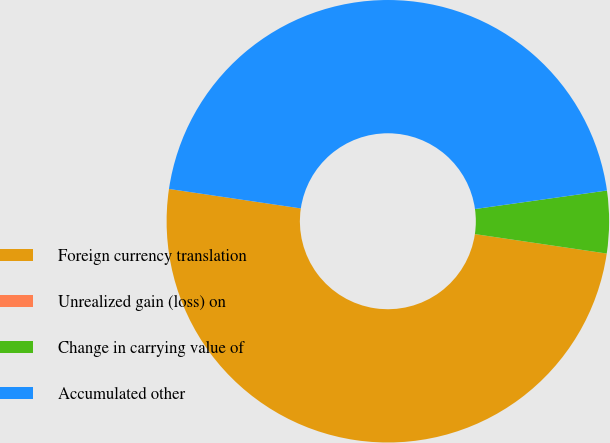<chart> <loc_0><loc_0><loc_500><loc_500><pie_chart><fcel>Foreign currency translation<fcel>Unrealized gain (loss) on<fcel>Change in carrying value of<fcel>Accumulated other<nl><fcel>50.0%<fcel>0.0%<fcel>4.55%<fcel>45.45%<nl></chart> 